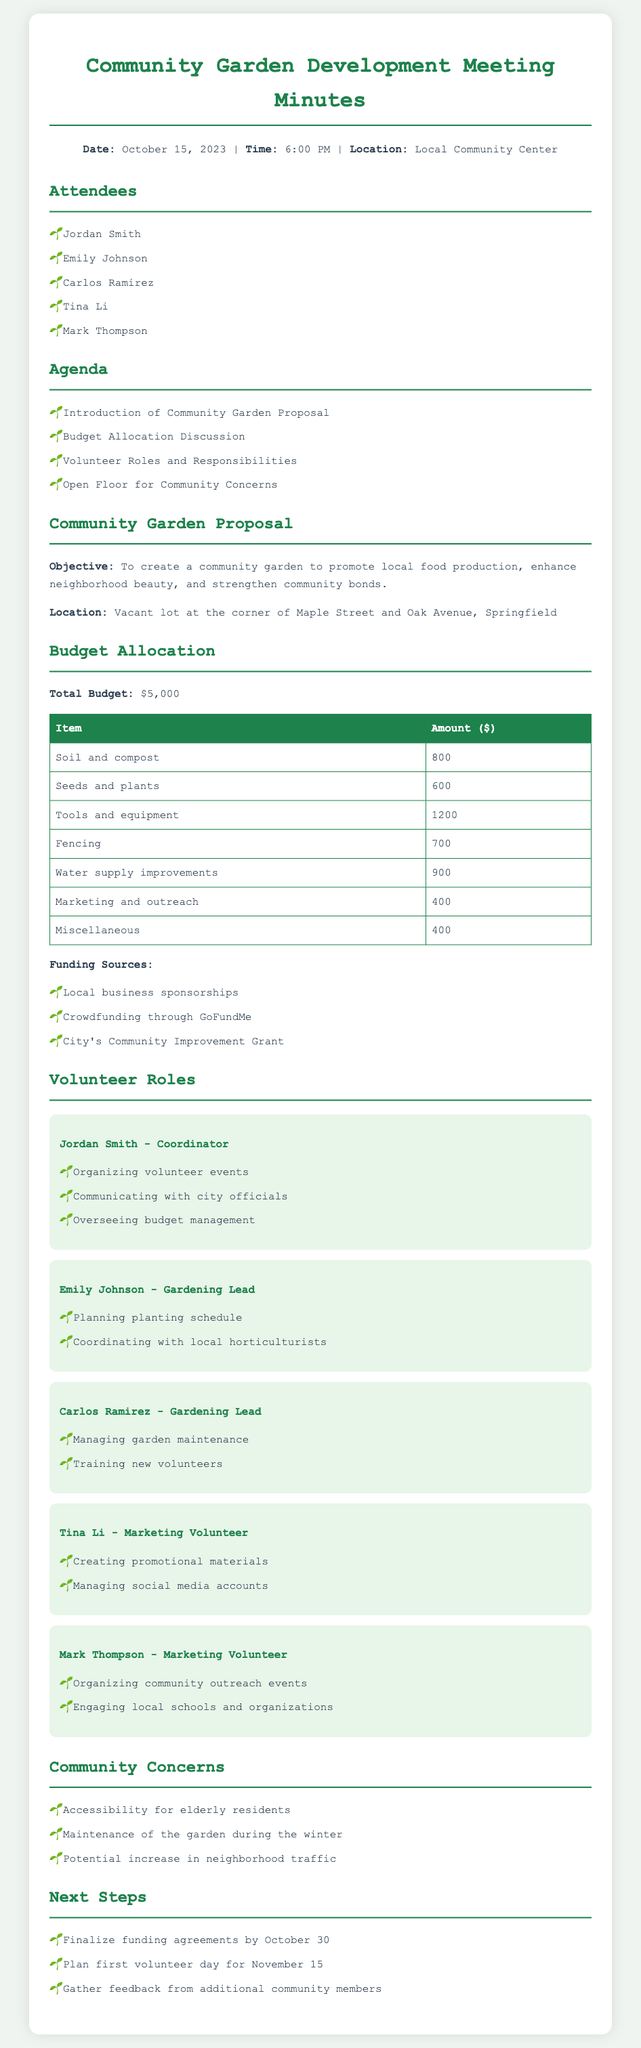what is the date of the meeting? The date of the meeting is clearly stated in the introduction section of the document.
Answer: October 15, 2023 what is the total budget for the community garden? The total budget is specified in the Budget Allocation section.
Answer: $5,000 who is the Coordinator of the project? The Coordinator's name is listed in the Volunteer Roles section of the document.
Answer: Jordan Smith what are the main funding sources for the garden? The funding sources are outlined in the Budget Allocation section.
Answer: Local business sponsorships, Crowdfunding through GoFundMe, City's Community Improvement Grant how many volunteer roles are listed in the document? The number of volunteer roles can be counted in the Volunteer Roles section.
Answer: 5 which location has been proposed for the community garden? The proposed location is mentioned in the Community Garden Proposal section.
Answer: Vacant lot at the corner of Maple Street and Oak Avenue, Springfield what community concern is related to accessibility? The specific community concern is mentioned in the Community Concerns section.
Answer: Accessibility for elderly residents when is the first volunteer day planned? The date for the first volunteer day is noted in the Next Steps section.
Answer: November 15 